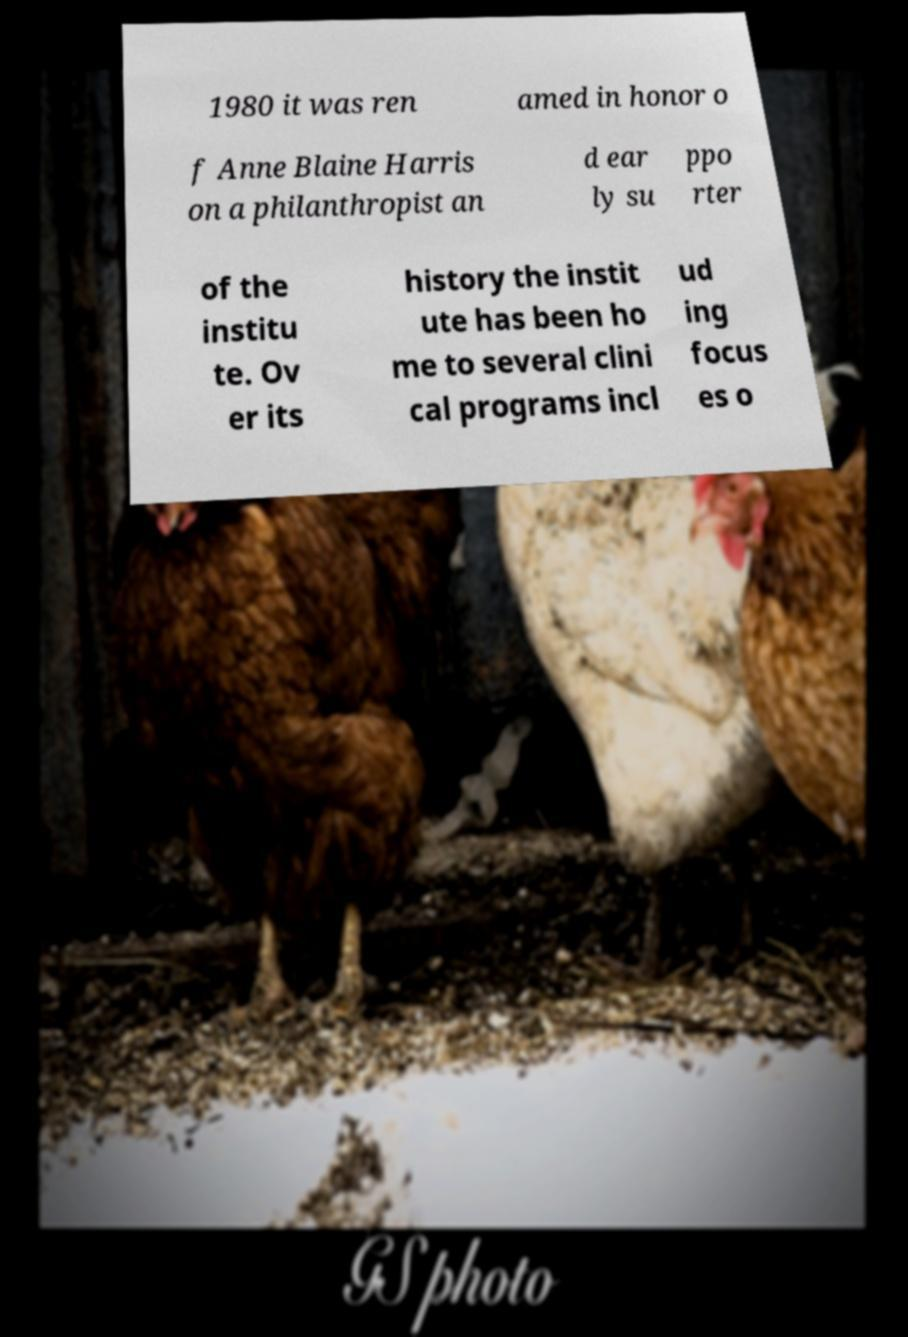Could you extract and type out the text from this image? 1980 it was ren amed in honor o f Anne Blaine Harris on a philanthropist an d ear ly su ppo rter of the institu te. Ov er its history the instit ute has been ho me to several clini cal programs incl ud ing focus es o 